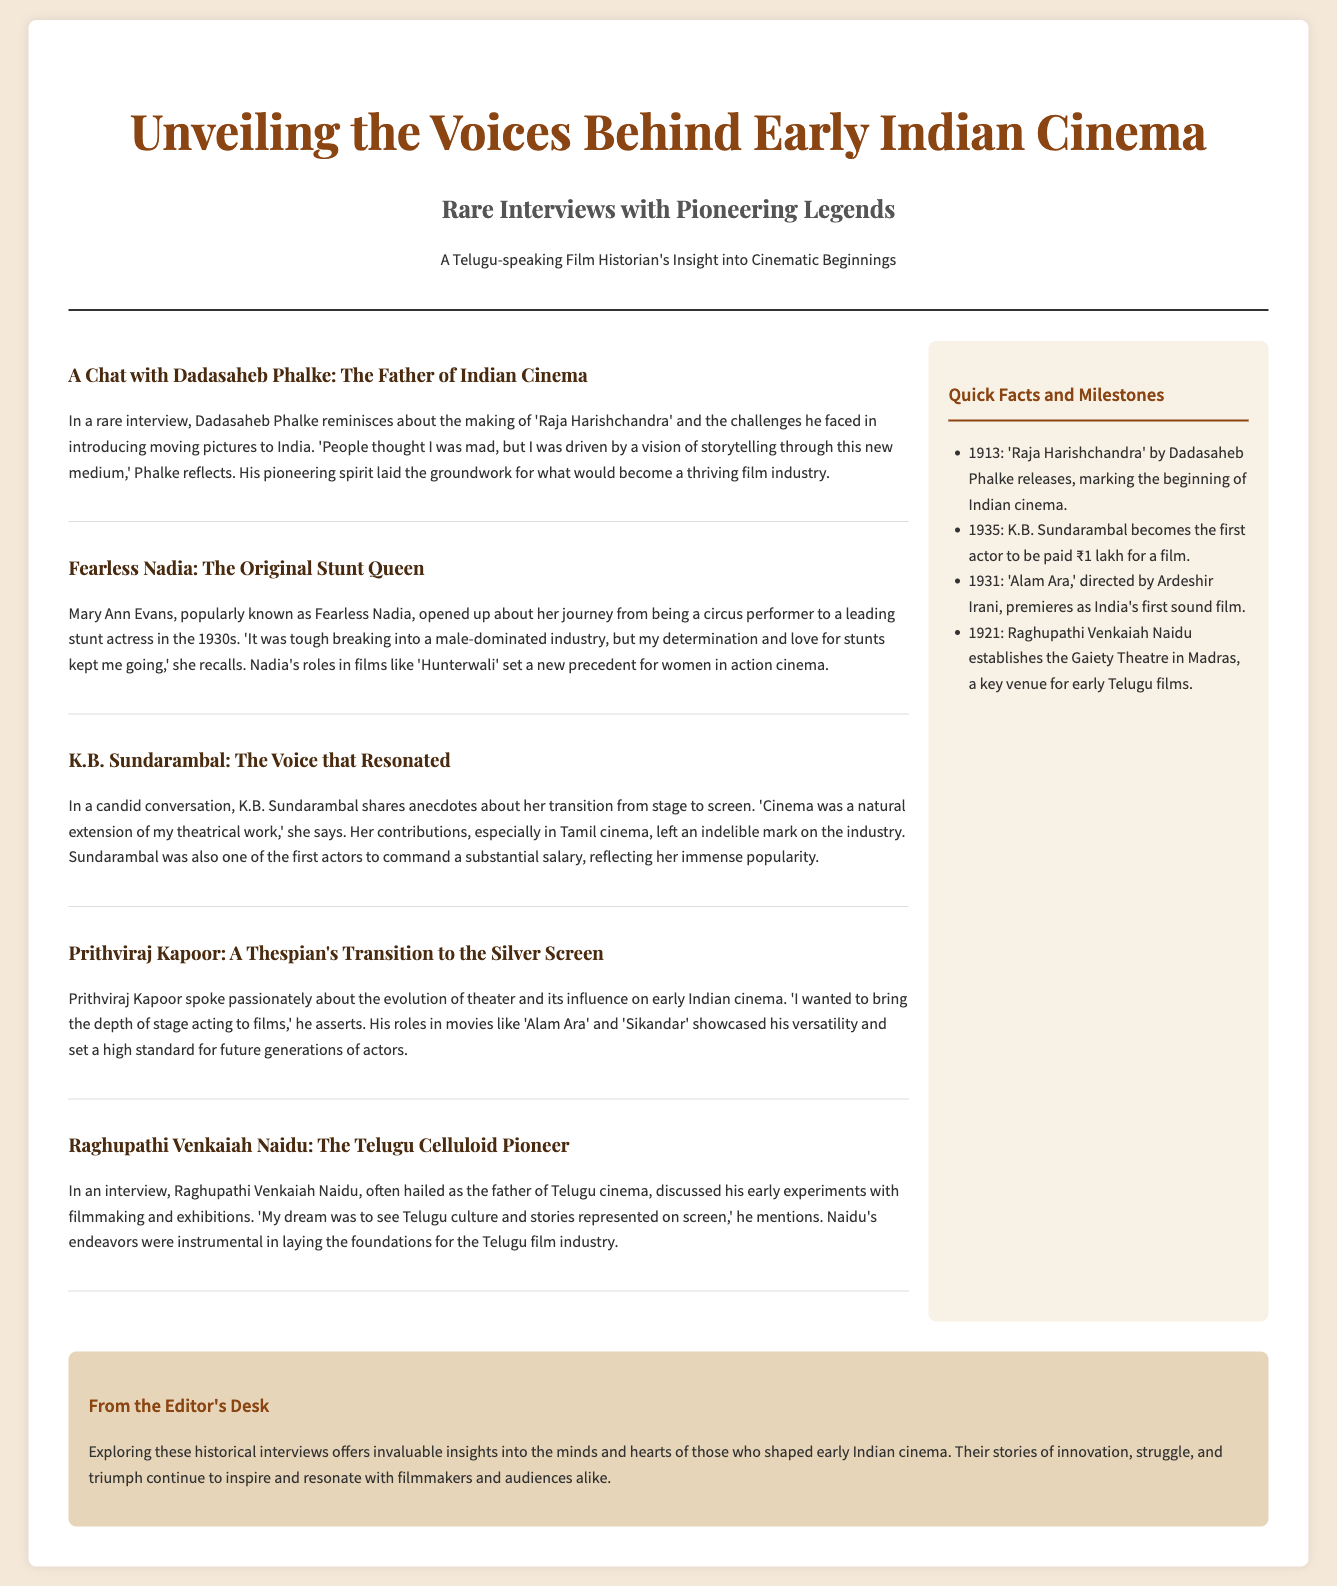What is the title of the newspaper? The title of the newspaper is prominently displayed at the top, giving insight into the topic covered.
Answer: Unveiling the Voices Behind Early Indian Cinema Who is referred to as the father of Indian cinema? The document mentions an interview with a key figure known for establishing Indian cinema.
Answer: Dadasaheb Phalke In which year did 'Raja Harishchandra' release? This detail is identified in the sidebar containing quick facts about early Indian cinema milestones.
Answer: 1913 Which stunt actress is featured in the interviews? The document includes an article highlighting an important female figure in early cinema known for her stunts.
Answer: Fearless Nadia What was K.B. Sundarambal's claim to fame regarding salaries? This information is stated in the interview about her career achievements in the film industry.
Answer: First actor to be paid ₹1 lakh for a film How did Raghupathi Venkaiah Naidu contribute to cinema? His role is explained in the interview detailing his efforts and goals for Telugu cinema.
Answer: Father of Telugu cinema What is mentioned as a key achievement of Prithviraj Kapoor? The document discusses his focus on theater's influence on cinema, demonstrating his passion for acting.
Answer: Evolution of theater and its influence on early Indian cinema Which film is referred to as India's first sound film? This information appears in the sidebar that lists significant milestones of early Indian cinema.
Answer: Alam Ara What unique aspect does the editorial note address? The editorial note emphasizes the importance and impact of the historical interviews mentioned throughout the document.
Answer: Insight into the minds and hearts of cinema pioneers 